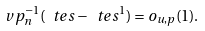<formula> <loc_0><loc_0><loc_500><loc_500>\ v p _ { n } ^ { - 1 } ( \ t e s - \ t e s ^ { 1 } ) = o _ { u , p } ( 1 ) .</formula> 